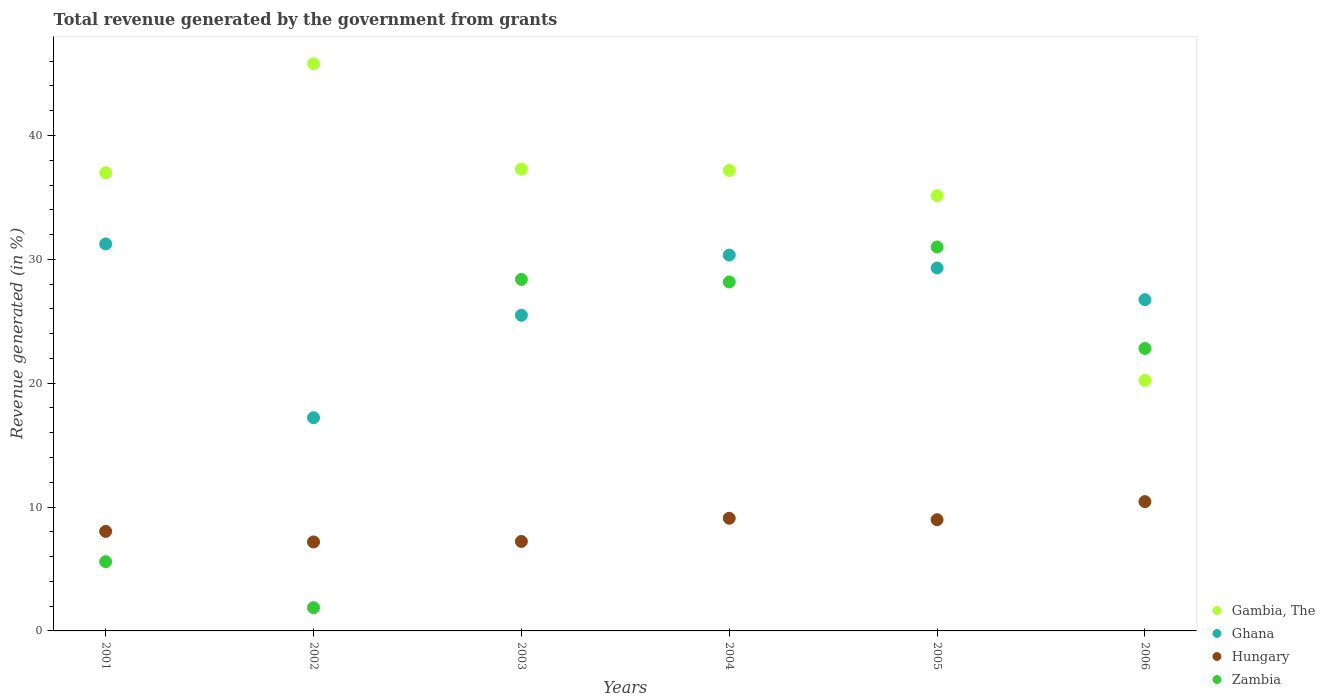How many different coloured dotlines are there?
Provide a succinct answer. 4. What is the total revenue generated in Gambia, The in 2005?
Provide a short and direct response. 35.15. Across all years, what is the maximum total revenue generated in Hungary?
Keep it short and to the point. 10.44. Across all years, what is the minimum total revenue generated in Ghana?
Provide a succinct answer. 17.21. What is the total total revenue generated in Gambia, The in the graph?
Offer a very short reply. 212.63. What is the difference between the total revenue generated in Zambia in 2003 and that in 2005?
Your answer should be compact. -2.62. What is the difference between the total revenue generated in Gambia, The in 2002 and the total revenue generated in Ghana in 2003?
Your answer should be compact. 20.31. What is the average total revenue generated in Zambia per year?
Your answer should be very brief. 19.64. In the year 2001, what is the difference between the total revenue generated in Ghana and total revenue generated in Zambia?
Ensure brevity in your answer.  25.66. In how many years, is the total revenue generated in Ghana greater than 16 %?
Provide a short and direct response. 6. What is the ratio of the total revenue generated in Zambia in 2003 to that in 2004?
Provide a succinct answer. 1.01. Is the total revenue generated in Zambia in 2003 less than that in 2006?
Offer a very short reply. No. What is the difference between the highest and the second highest total revenue generated in Gambia, The?
Keep it short and to the point. 8.51. What is the difference between the highest and the lowest total revenue generated in Zambia?
Keep it short and to the point. 29.12. Is the sum of the total revenue generated in Ghana in 2002 and 2006 greater than the maximum total revenue generated in Hungary across all years?
Offer a very short reply. Yes. Does the total revenue generated in Hungary monotonically increase over the years?
Make the answer very short. No. Is the total revenue generated in Zambia strictly less than the total revenue generated in Ghana over the years?
Make the answer very short. No. How many dotlines are there?
Your answer should be very brief. 4. How many years are there in the graph?
Keep it short and to the point. 6. Are the values on the major ticks of Y-axis written in scientific E-notation?
Your response must be concise. No. Where does the legend appear in the graph?
Your answer should be very brief. Bottom right. How many legend labels are there?
Offer a very short reply. 4. What is the title of the graph?
Provide a short and direct response. Total revenue generated by the government from grants. Does "Madagascar" appear as one of the legend labels in the graph?
Provide a short and direct response. No. What is the label or title of the X-axis?
Offer a terse response. Years. What is the label or title of the Y-axis?
Offer a very short reply. Revenue generated (in %). What is the Revenue generated (in %) in Gambia, The in 2001?
Ensure brevity in your answer.  36.99. What is the Revenue generated (in %) of Ghana in 2001?
Ensure brevity in your answer.  31.25. What is the Revenue generated (in %) of Hungary in 2001?
Provide a short and direct response. 8.04. What is the Revenue generated (in %) of Zambia in 2001?
Your answer should be very brief. 5.59. What is the Revenue generated (in %) of Gambia, The in 2002?
Keep it short and to the point. 45.79. What is the Revenue generated (in %) of Ghana in 2002?
Make the answer very short. 17.21. What is the Revenue generated (in %) of Hungary in 2002?
Keep it short and to the point. 7.18. What is the Revenue generated (in %) of Zambia in 2002?
Your response must be concise. 1.88. What is the Revenue generated (in %) in Gambia, The in 2003?
Make the answer very short. 37.29. What is the Revenue generated (in %) in Ghana in 2003?
Your answer should be compact. 25.49. What is the Revenue generated (in %) of Hungary in 2003?
Ensure brevity in your answer.  7.22. What is the Revenue generated (in %) of Zambia in 2003?
Your response must be concise. 28.38. What is the Revenue generated (in %) in Gambia, The in 2004?
Offer a terse response. 37.18. What is the Revenue generated (in %) in Ghana in 2004?
Your answer should be compact. 30.35. What is the Revenue generated (in %) in Hungary in 2004?
Make the answer very short. 9.1. What is the Revenue generated (in %) of Zambia in 2004?
Ensure brevity in your answer.  28.18. What is the Revenue generated (in %) of Gambia, The in 2005?
Offer a terse response. 35.15. What is the Revenue generated (in %) in Ghana in 2005?
Make the answer very short. 29.3. What is the Revenue generated (in %) of Hungary in 2005?
Provide a succinct answer. 8.98. What is the Revenue generated (in %) in Zambia in 2005?
Provide a succinct answer. 31. What is the Revenue generated (in %) in Gambia, The in 2006?
Offer a very short reply. 20.23. What is the Revenue generated (in %) of Ghana in 2006?
Your response must be concise. 26.75. What is the Revenue generated (in %) in Hungary in 2006?
Provide a succinct answer. 10.44. What is the Revenue generated (in %) in Zambia in 2006?
Provide a short and direct response. 22.81. Across all years, what is the maximum Revenue generated (in %) of Gambia, The?
Your answer should be compact. 45.79. Across all years, what is the maximum Revenue generated (in %) of Ghana?
Your answer should be compact. 31.25. Across all years, what is the maximum Revenue generated (in %) in Hungary?
Ensure brevity in your answer.  10.44. Across all years, what is the maximum Revenue generated (in %) of Zambia?
Provide a short and direct response. 31. Across all years, what is the minimum Revenue generated (in %) of Gambia, The?
Offer a very short reply. 20.23. Across all years, what is the minimum Revenue generated (in %) of Ghana?
Provide a succinct answer. 17.21. Across all years, what is the minimum Revenue generated (in %) in Hungary?
Ensure brevity in your answer.  7.18. Across all years, what is the minimum Revenue generated (in %) in Zambia?
Give a very brief answer. 1.88. What is the total Revenue generated (in %) of Gambia, The in the graph?
Give a very brief answer. 212.63. What is the total Revenue generated (in %) of Ghana in the graph?
Provide a short and direct response. 160.34. What is the total Revenue generated (in %) of Hungary in the graph?
Keep it short and to the point. 50.96. What is the total Revenue generated (in %) in Zambia in the graph?
Provide a short and direct response. 117.83. What is the difference between the Revenue generated (in %) of Gambia, The in 2001 and that in 2002?
Your response must be concise. -8.8. What is the difference between the Revenue generated (in %) of Ghana in 2001 and that in 2002?
Ensure brevity in your answer.  14.04. What is the difference between the Revenue generated (in %) in Hungary in 2001 and that in 2002?
Provide a succinct answer. 0.85. What is the difference between the Revenue generated (in %) of Zambia in 2001 and that in 2002?
Your answer should be compact. 3.71. What is the difference between the Revenue generated (in %) in Gambia, The in 2001 and that in 2003?
Provide a short and direct response. -0.3. What is the difference between the Revenue generated (in %) in Ghana in 2001 and that in 2003?
Your response must be concise. 5.76. What is the difference between the Revenue generated (in %) of Hungary in 2001 and that in 2003?
Keep it short and to the point. 0.81. What is the difference between the Revenue generated (in %) of Zambia in 2001 and that in 2003?
Ensure brevity in your answer.  -22.79. What is the difference between the Revenue generated (in %) in Gambia, The in 2001 and that in 2004?
Offer a terse response. -0.19. What is the difference between the Revenue generated (in %) in Ghana in 2001 and that in 2004?
Offer a terse response. 0.9. What is the difference between the Revenue generated (in %) in Hungary in 2001 and that in 2004?
Offer a terse response. -1.06. What is the difference between the Revenue generated (in %) in Zambia in 2001 and that in 2004?
Your response must be concise. -22.59. What is the difference between the Revenue generated (in %) of Gambia, The in 2001 and that in 2005?
Your response must be concise. 1.84. What is the difference between the Revenue generated (in %) in Ghana in 2001 and that in 2005?
Ensure brevity in your answer.  1.94. What is the difference between the Revenue generated (in %) in Hungary in 2001 and that in 2005?
Provide a short and direct response. -0.94. What is the difference between the Revenue generated (in %) of Zambia in 2001 and that in 2005?
Give a very brief answer. -25.41. What is the difference between the Revenue generated (in %) in Gambia, The in 2001 and that in 2006?
Your answer should be compact. 16.76. What is the difference between the Revenue generated (in %) in Ghana in 2001 and that in 2006?
Offer a terse response. 4.5. What is the difference between the Revenue generated (in %) of Hungary in 2001 and that in 2006?
Provide a short and direct response. -2.4. What is the difference between the Revenue generated (in %) of Zambia in 2001 and that in 2006?
Ensure brevity in your answer.  -17.22. What is the difference between the Revenue generated (in %) of Gambia, The in 2002 and that in 2003?
Your response must be concise. 8.51. What is the difference between the Revenue generated (in %) of Ghana in 2002 and that in 2003?
Your answer should be very brief. -8.27. What is the difference between the Revenue generated (in %) of Hungary in 2002 and that in 2003?
Offer a very short reply. -0.04. What is the difference between the Revenue generated (in %) in Zambia in 2002 and that in 2003?
Offer a very short reply. -26.51. What is the difference between the Revenue generated (in %) of Gambia, The in 2002 and that in 2004?
Keep it short and to the point. 8.61. What is the difference between the Revenue generated (in %) in Ghana in 2002 and that in 2004?
Your response must be concise. -13.14. What is the difference between the Revenue generated (in %) in Hungary in 2002 and that in 2004?
Provide a succinct answer. -1.91. What is the difference between the Revenue generated (in %) of Zambia in 2002 and that in 2004?
Keep it short and to the point. -26.3. What is the difference between the Revenue generated (in %) in Gambia, The in 2002 and that in 2005?
Ensure brevity in your answer.  10.65. What is the difference between the Revenue generated (in %) of Ghana in 2002 and that in 2005?
Ensure brevity in your answer.  -12.09. What is the difference between the Revenue generated (in %) in Hungary in 2002 and that in 2005?
Give a very brief answer. -1.79. What is the difference between the Revenue generated (in %) of Zambia in 2002 and that in 2005?
Ensure brevity in your answer.  -29.12. What is the difference between the Revenue generated (in %) of Gambia, The in 2002 and that in 2006?
Your answer should be very brief. 25.56. What is the difference between the Revenue generated (in %) of Ghana in 2002 and that in 2006?
Make the answer very short. -9.54. What is the difference between the Revenue generated (in %) of Hungary in 2002 and that in 2006?
Make the answer very short. -3.26. What is the difference between the Revenue generated (in %) in Zambia in 2002 and that in 2006?
Your answer should be very brief. -20.93. What is the difference between the Revenue generated (in %) of Gambia, The in 2003 and that in 2004?
Provide a succinct answer. 0.11. What is the difference between the Revenue generated (in %) in Ghana in 2003 and that in 2004?
Give a very brief answer. -4.86. What is the difference between the Revenue generated (in %) in Hungary in 2003 and that in 2004?
Your answer should be very brief. -1.87. What is the difference between the Revenue generated (in %) of Zambia in 2003 and that in 2004?
Provide a short and direct response. 0.2. What is the difference between the Revenue generated (in %) of Gambia, The in 2003 and that in 2005?
Offer a terse response. 2.14. What is the difference between the Revenue generated (in %) in Ghana in 2003 and that in 2005?
Keep it short and to the point. -3.82. What is the difference between the Revenue generated (in %) in Hungary in 2003 and that in 2005?
Your response must be concise. -1.76. What is the difference between the Revenue generated (in %) in Zambia in 2003 and that in 2005?
Keep it short and to the point. -2.62. What is the difference between the Revenue generated (in %) in Gambia, The in 2003 and that in 2006?
Your answer should be compact. 17.06. What is the difference between the Revenue generated (in %) in Ghana in 2003 and that in 2006?
Keep it short and to the point. -1.26. What is the difference between the Revenue generated (in %) of Hungary in 2003 and that in 2006?
Your response must be concise. -3.22. What is the difference between the Revenue generated (in %) in Zambia in 2003 and that in 2006?
Your answer should be compact. 5.58. What is the difference between the Revenue generated (in %) in Gambia, The in 2004 and that in 2005?
Provide a succinct answer. 2.04. What is the difference between the Revenue generated (in %) of Ghana in 2004 and that in 2005?
Make the answer very short. 1.04. What is the difference between the Revenue generated (in %) in Hungary in 2004 and that in 2005?
Make the answer very short. 0.12. What is the difference between the Revenue generated (in %) of Zambia in 2004 and that in 2005?
Offer a very short reply. -2.82. What is the difference between the Revenue generated (in %) of Gambia, The in 2004 and that in 2006?
Ensure brevity in your answer.  16.95. What is the difference between the Revenue generated (in %) of Ghana in 2004 and that in 2006?
Give a very brief answer. 3.6. What is the difference between the Revenue generated (in %) of Hungary in 2004 and that in 2006?
Keep it short and to the point. -1.35. What is the difference between the Revenue generated (in %) of Zambia in 2004 and that in 2006?
Offer a terse response. 5.37. What is the difference between the Revenue generated (in %) in Gambia, The in 2005 and that in 2006?
Provide a short and direct response. 14.92. What is the difference between the Revenue generated (in %) of Ghana in 2005 and that in 2006?
Ensure brevity in your answer.  2.56. What is the difference between the Revenue generated (in %) in Hungary in 2005 and that in 2006?
Provide a succinct answer. -1.46. What is the difference between the Revenue generated (in %) in Zambia in 2005 and that in 2006?
Give a very brief answer. 8.19. What is the difference between the Revenue generated (in %) of Gambia, The in 2001 and the Revenue generated (in %) of Ghana in 2002?
Your response must be concise. 19.78. What is the difference between the Revenue generated (in %) in Gambia, The in 2001 and the Revenue generated (in %) in Hungary in 2002?
Give a very brief answer. 29.81. What is the difference between the Revenue generated (in %) in Gambia, The in 2001 and the Revenue generated (in %) in Zambia in 2002?
Provide a succinct answer. 35.12. What is the difference between the Revenue generated (in %) of Ghana in 2001 and the Revenue generated (in %) of Hungary in 2002?
Make the answer very short. 24.06. What is the difference between the Revenue generated (in %) in Ghana in 2001 and the Revenue generated (in %) in Zambia in 2002?
Make the answer very short. 29.37. What is the difference between the Revenue generated (in %) of Hungary in 2001 and the Revenue generated (in %) of Zambia in 2002?
Keep it short and to the point. 6.16. What is the difference between the Revenue generated (in %) of Gambia, The in 2001 and the Revenue generated (in %) of Ghana in 2003?
Give a very brief answer. 11.51. What is the difference between the Revenue generated (in %) in Gambia, The in 2001 and the Revenue generated (in %) in Hungary in 2003?
Provide a short and direct response. 29.77. What is the difference between the Revenue generated (in %) in Gambia, The in 2001 and the Revenue generated (in %) in Zambia in 2003?
Provide a short and direct response. 8.61. What is the difference between the Revenue generated (in %) in Ghana in 2001 and the Revenue generated (in %) in Hungary in 2003?
Offer a terse response. 24.02. What is the difference between the Revenue generated (in %) of Ghana in 2001 and the Revenue generated (in %) of Zambia in 2003?
Make the answer very short. 2.87. What is the difference between the Revenue generated (in %) in Hungary in 2001 and the Revenue generated (in %) in Zambia in 2003?
Offer a very short reply. -20.35. What is the difference between the Revenue generated (in %) of Gambia, The in 2001 and the Revenue generated (in %) of Ghana in 2004?
Offer a terse response. 6.65. What is the difference between the Revenue generated (in %) of Gambia, The in 2001 and the Revenue generated (in %) of Hungary in 2004?
Ensure brevity in your answer.  27.9. What is the difference between the Revenue generated (in %) in Gambia, The in 2001 and the Revenue generated (in %) in Zambia in 2004?
Offer a very short reply. 8.81. What is the difference between the Revenue generated (in %) in Ghana in 2001 and the Revenue generated (in %) in Hungary in 2004?
Make the answer very short. 22.15. What is the difference between the Revenue generated (in %) of Ghana in 2001 and the Revenue generated (in %) of Zambia in 2004?
Your response must be concise. 3.07. What is the difference between the Revenue generated (in %) of Hungary in 2001 and the Revenue generated (in %) of Zambia in 2004?
Offer a terse response. -20.14. What is the difference between the Revenue generated (in %) in Gambia, The in 2001 and the Revenue generated (in %) in Ghana in 2005?
Provide a short and direct response. 7.69. What is the difference between the Revenue generated (in %) in Gambia, The in 2001 and the Revenue generated (in %) in Hungary in 2005?
Provide a short and direct response. 28.01. What is the difference between the Revenue generated (in %) in Gambia, The in 2001 and the Revenue generated (in %) in Zambia in 2005?
Your answer should be very brief. 5.99. What is the difference between the Revenue generated (in %) in Ghana in 2001 and the Revenue generated (in %) in Hungary in 2005?
Keep it short and to the point. 22.27. What is the difference between the Revenue generated (in %) in Ghana in 2001 and the Revenue generated (in %) in Zambia in 2005?
Your answer should be compact. 0.25. What is the difference between the Revenue generated (in %) of Hungary in 2001 and the Revenue generated (in %) of Zambia in 2005?
Keep it short and to the point. -22.96. What is the difference between the Revenue generated (in %) in Gambia, The in 2001 and the Revenue generated (in %) in Ghana in 2006?
Keep it short and to the point. 10.24. What is the difference between the Revenue generated (in %) in Gambia, The in 2001 and the Revenue generated (in %) in Hungary in 2006?
Make the answer very short. 26.55. What is the difference between the Revenue generated (in %) of Gambia, The in 2001 and the Revenue generated (in %) of Zambia in 2006?
Offer a very short reply. 14.19. What is the difference between the Revenue generated (in %) in Ghana in 2001 and the Revenue generated (in %) in Hungary in 2006?
Your answer should be very brief. 20.81. What is the difference between the Revenue generated (in %) in Ghana in 2001 and the Revenue generated (in %) in Zambia in 2006?
Your answer should be very brief. 8.44. What is the difference between the Revenue generated (in %) of Hungary in 2001 and the Revenue generated (in %) of Zambia in 2006?
Your answer should be compact. -14.77. What is the difference between the Revenue generated (in %) of Gambia, The in 2002 and the Revenue generated (in %) of Ghana in 2003?
Keep it short and to the point. 20.31. What is the difference between the Revenue generated (in %) of Gambia, The in 2002 and the Revenue generated (in %) of Hungary in 2003?
Make the answer very short. 38.57. What is the difference between the Revenue generated (in %) in Gambia, The in 2002 and the Revenue generated (in %) in Zambia in 2003?
Give a very brief answer. 17.41. What is the difference between the Revenue generated (in %) in Ghana in 2002 and the Revenue generated (in %) in Hungary in 2003?
Your answer should be very brief. 9.99. What is the difference between the Revenue generated (in %) of Ghana in 2002 and the Revenue generated (in %) of Zambia in 2003?
Provide a succinct answer. -11.17. What is the difference between the Revenue generated (in %) in Hungary in 2002 and the Revenue generated (in %) in Zambia in 2003?
Provide a short and direct response. -21.2. What is the difference between the Revenue generated (in %) of Gambia, The in 2002 and the Revenue generated (in %) of Ghana in 2004?
Provide a succinct answer. 15.45. What is the difference between the Revenue generated (in %) of Gambia, The in 2002 and the Revenue generated (in %) of Hungary in 2004?
Give a very brief answer. 36.7. What is the difference between the Revenue generated (in %) of Gambia, The in 2002 and the Revenue generated (in %) of Zambia in 2004?
Offer a very short reply. 17.61. What is the difference between the Revenue generated (in %) in Ghana in 2002 and the Revenue generated (in %) in Hungary in 2004?
Your response must be concise. 8.12. What is the difference between the Revenue generated (in %) in Ghana in 2002 and the Revenue generated (in %) in Zambia in 2004?
Your answer should be very brief. -10.97. What is the difference between the Revenue generated (in %) of Hungary in 2002 and the Revenue generated (in %) of Zambia in 2004?
Give a very brief answer. -20.99. What is the difference between the Revenue generated (in %) in Gambia, The in 2002 and the Revenue generated (in %) in Ghana in 2005?
Give a very brief answer. 16.49. What is the difference between the Revenue generated (in %) in Gambia, The in 2002 and the Revenue generated (in %) in Hungary in 2005?
Your response must be concise. 36.81. What is the difference between the Revenue generated (in %) in Gambia, The in 2002 and the Revenue generated (in %) in Zambia in 2005?
Your response must be concise. 14.8. What is the difference between the Revenue generated (in %) in Ghana in 2002 and the Revenue generated (in %) in Hungary in 2005?
Keep it short and to the point. 8.23. What is the difference between the Revenue generated (in %) of Ghana in 2002 and the Revenue generated (in %) of Zambia in 2005?
Your answer should be very brief. -13.79. What is the difference between the Revenue generated (in %) of Hungary in 2002 and the Revenue generated (in %) of Zambia in 2005?
Give a very brief answer. -23.81. What is the difference between the Revenue generated (in %) in Gambia, The in 2002 and the Revenue generated (in %) in Ghana in 2006?
Give a very brief answer. 19.05. What is the difference between the Revenue generated (in %) in Gambia, The in 2002 and the Revenue generated (in %) in Hungary in 2006?
Give a very brief answer. 35.35. What is the difference between the Revenue generated (in %) of Gambia, The in 2002 and the Revenue generated (in %) of Zambia in 2006?
Ensure brevity in your answer.  22.99. What is the difference between the Revenue generated (in %) of Ghana in 2002 and the Revenue generated (in %) of Hungary in 2006?
Make the answer very short. 6.77. What is the difference between the Revenue generated (in %) of Ghana in 2002 and the Revenue generated (in %) of Zambia in 2006?
Provide a short and direct response. -5.6. What is the difference between the Revenue generated (in %) in Hungary in 2002 and the Revenue generated (in %) in Zambia in 2006?
Provide a succinct answer. -15.62. What is the difference between the Revenue generated (in %) in Gambia, The in 2003 and the Revenue generated (in %) in Ghana in 2004?
Provide a short and direct response. 6.94. What is the difference between the Revenue generated (in %) in Gambia, The in 2003 and the Revenue generated (in %) in Hungary in 2004?
Your response must be concise. 28.19. What is the difference between the Revenue generated (in %) of Gambia, The in 2003 and the Revenue generated (in %) of Zambia in 2004?
Make the answer very short. 9.11. What is the difference between the Revenue generated (in %) of Ghana in 2003 and the Revenue generated (in %) of Hungary in 2004?
Offer a terse response. 16.39. What is the difference between the Revenue generated (in %) in Ghana in 2003 and the Revenue generated (in %) in Zambia in 2004?
Your answer should be very brief. -2.69. What is the difference between the Revenue generated (in %) of Hungary in 2003 and the Revenue generated (in %) of Zambia in 2004?
Make the answer very short. -20.95. What is the difference between the Revenue generated (in %) in Gambia, The in 2003 and the Revenue generated (in %) in Ghana in 2005?
Provide a short and direct response. 7.98. What is the difference between the Revenue generated (in %) of Gambia, The in 2003 and the Revenue generated (in %) of Hungary in 2005?
Make the answer very short. 28.31. What is the difference between the Revenue generated (in %) of Gambia, The in 2003 and the Revenue generated (in %) of Zambia in 2005?
Your response must be concise. 6.29. What is the difference between the Revenue generated (in %) of Ghana in 2003 and the Revenue generated (in %) of Hungary in 2005?
Your answer should be very brief. 16.51. What is the difference between the Revenue generated (in %) in Ghana in 2003 and the Revenue generated (in %) in Zambia in 2005?
Your answer should be very brief. -5.51. What is the difference between the Revenue generated (in %) in Hungary in 2003 and the Revenue generated (in %) in Zambia in 2005?
Your answer should be very brief. -23.77. What is the difference between the Revenue generated (in %) of Gambia, The in 2003 and the Revenue generated (in %) of Ghana in 2006?
Offer a terse response. 10.54. What is the difference between the Revenue generated (in %) of Gambia, The in 2003 and the Revenue generated (in %) of Hungary in 2006?
Keep it short and to the point. 26.85. What is the difference between the Revenue generated (in %) in Gambia, The in 2003 and the Revenue generated (in %) in Zambia in 2006?
Your response must be concise. 14.48. What is the difference between the Revenue generated (in %) in Ghana in 2003 and the Revenue generated (in %) in Hungary in 2006?
Ensure brevity in your answer.  15.04. What is the difference between the Revenue generated (in %) in Ghana in 2003 and the Revenue generated (in %) in Zambia in 2006?
Keep it short and to the point. 2.68. What is the difference between the Revenue generated (in %) in Hungary in 2003 and the Revenue generated (in %) in Zambia in 2006?
Make the answer very short. -15.58. What is the difference between the Revenue generated (in %) in Gambia, The in 2004 and the Revenue generated (in %) in Ghana in 2005?
Provide a succinct answer. 7.88. What is the difference between the Revenue generated (in %) of Gambia, The in 2004 and the Revenue generated (in %) of Hungary in 2005?
Offer a very short reply. 28.2. What is the difference between the Revenue generated (in %) of Gambia, The in 2004 and the Revenue generated (in %) of Zambia in 2005?
Give a very brief answer. 6.18. What is the difference between the Revenue generated (in %) of Ghana in 2004 and the Revenue generated (in %) of Hungary in 2005?
Offer a terse response. 21.37. What is the difference between the Revenue generated (in %) in Ghana in 2004 and the Revenue generated (in %) in Zambia in 2005?
Give a very brief answer. -0.65. What is the difference between the Revenue generated (in %) in Hungary in 2004 and the Revenue generated (in %) in Zambia in 2005?
Give a very brief answer. -21.9. What is the difference between the Revenue generated (in %) of Gambia, The in 2004 and the Revenue generated (in %) of Ghana in 2006?
Keep it short and to the point. 10.44. What is the difference between the Revenue generated (in %) of Gambia, The in 2004 and the Revenue generated (in %) of Hungary in 2006?
Keep it short and to the point. 26.74. What is the difference between the Revenue generated (in %) in Gambia, The in 2004 and the Revenue generated (in %) in Zambia in 2006?
Make the answer very short. 14.38. What is the difference between the Revenue generated (in %) of Ghana in 2004 and the Revenue generated (in %) of Hungary in 2006?
Ensure brevity in your answer.  19.91. What is the difference between the Revenue generated (in %) of Ghana in 2004 and the Revenue generated (in %) of Zambia in 2006?
Provide a succinct answer. 7.54. What is the difference between the Revenue generated (in %) in Hungary in 2004 and the Revenue generated (in %) in Zambia in 2006?
Make the answer very short. -13.71. What is the difference between the Revenue generated (in %) in Gambia, The in 2005 and the Revenue generated (in %) in Ghana in 2006?
Your answer should be very brief. 8.4. What is the difference between the Revenue generated (in %) in Gambia, The in 2005 and the Revenue generated (in %) in Hungary in 2006?
Your answer should be very brief. 24.71. What is the difference between the Revenue generated (in %) of Gambia, The in 2005 and the Revenue generated (in %) of Zambia in 2006?
Your answer should be very brief. 12.34. What is the difference between the Revenue generated (in %) of Ghana in 2005 and the Revenue generated (in %) of Hungary in 2006?
Keep it short and to the point. 18.86. What is the difference between the Revenue generated (in %) in Ghana in 2005 and the Revenue generated (in %) in Zambia in 2006?
Your response must be concise. 6.5. What is the difference between the Revenue generated (in %) of Hungary in 2005 and the Revenue generated (in %) of Zambia in 2006?
Your answer should be compact. -13.83. What is the average Revenue generated (in %) in Gambia, The per year?
Your answer should be compact. 35.44. What is the average Revenue generated (in %) in Ghana per year?
Your answer should be very brief. 26.72. What is the average Revenue generated (in %) in Hungary per year?
Give a very brief answer. 8.49. What is the average Revenue generated (in %) in Zambia per year?
Offer a very short reply. 19.64. In the year 2001, what is the difference between the Revenue generated (in %) of Gambia, The and Revenue generated (in %) of Ghana?
Ensure brevity in your answer.  5.74. In the year 2001, what is the difference between the Revenue generated (in %) of Gambia, The and Revenue generated (in %) of Hungary?
Offer a very short reply. 28.96. In the year 2001, what is the difference between the Revenue generated (in %) of Gambia, The and Revenue generated (in %) of Zambia?
Ensure brevity in your answer.  31.4. In the year 2001, what is the difference between the Revenue generated (in %) in Ghana and Revenue generated (in %) in Hungary?
Offer a very short reply. 23.21. In the year 2001, what is the difference between the Revenue generated (in %) of Ghana and Revenue generated (in %) of Zambia?
Provide a short and direct response. 25.66. In the year 2001, what is the difference between the Revenue generated (in %) in Hungary and Revenue generated (in %) in Zambia?
Provide a succinct answer. 2.45. In the year 2002, what is the difference between the Revenue generated (in %) in Gambia, The and Revenue generated (in %) in Ghana?
Give a very brief answer. 28.58. In the year 2002, what is the difference between the Revenue generated (in %) of Gambia, The and Revenue generated (in %) of Hungary?
Keep it short and to the point. 38.61. In the year 2002, what is the difference between the Revenue generated (in %) in Gambia, The and Revenue generated (in %) in Zambia?
Provide a succinct answer. 43.92. In the year 2002, what is the difference between the Revenue generated (in %) in Ghana and Revenue generated (in %) in Hungary?
Ensure brevity in your answer.  10.03. In the year 2002, what is the difference between the Revenue generated (in %) in Ghana and Revenue generated (in %) in Zambia?
Offer a very short reply. 15.34. In the year 2002, what is the difference between the Revenue generated (in %) of Hungary and Revenue generated (in %) of Zambia?
Provide a short and direct response. 5.31. In the year 2003, what is the difference between the Revenue generated (in %) in Gambia, The and Revenue generated (in %) in Ghana?
Your response must be concise. 11.8. In the year 2003, what is the difference between the Revenue generated (in %) in Gambia, The and Revenue generated (in %) in Hungary?
Your answer should be very brief. 30.06. In the year 2003, what is the difference between the Revenue generated (in %) of Gambia, The and Revenue generated (in %) of Zambia?
Keep it short and to the point. 8.9. In the year 2003, what is the difference between the Revenue generated (in %) in Ghana and Revenue generated (in %) in Hungary?
Ensure brevity in your answer.  18.26. In the year 2003, what is the difference between the Revenue generated (in %) of Ghana and Revenue generated (in %) of Zambia?
Offer a terse response. -2.9. In the year 2003, what is the difference between the Revenue generated (in %) of Hungary and Revenue generated (in %) of Zambia?
Offer a very short reply. -21.16. In the year 2004, what is the difference between the Revenue generated (in %) of Gambia, The and Revenue generated (in %) of Ghana?
Make the answer very short. 6.84. In the year 2004, what is the difference between the Revenue generated (in %) of Gambia, The and Revenue generated (in %) of Hungary?
Make the answer very short. 28.09. In the year 2004, what is the difference between the Revenue generated (in %) of Gambia, The and Revenue generated (in %) of Zambia?
Give a very brief answer. 9. In the year 2004, what is the difference between the Revenue generated (in %) of Ghana and Revenue generated (in %) of Hungary?
Your response must be concise. 21.25. In the year 2004, what is the difference between the Revenue generated (in %) of Ghana and Revenue generated (in %) of Zambia?
Your response must be concise. 2.17. In the year 2004, what is the difference between the Revenue generated (in %) in Hungary and Revenue generated (in %) in Zambia?
Your answer should be very brief. -19.08. In the year 2005, what is the difference between the Revenue generated (in %) in Gambia, The and Revenue generated (in %) in Ghana?
Ensure brevity in your answer.  5.84. In the year 2005, what is the difference between the Revenue generated (in %) of Gambia, The and Revenue generated (in %) of Hungary?
Provide a short and direct response. 26.17. In the year 2005, what is the difference between the Revenue generated (in %) in Gambia, The and Revenue generated (in %) in Zambia?
Your response must be concise. 4.15. In the year 2005, what is the difference between the Revenue generated (in %) in Ghana and Revenue generated (in %) in Hungary?
Keep it short and to the point. 20.32. In the year 2005, what is the difference between the Revenue generated (in %) in Ghana and Revenue generated (in %) in Zambia?
Make the answer very short. -1.7. In the year 2005, what is the difference between the Revenue generated (in %) of Hungary and Revenue generated (in %) of Zambia?
Your response must be concise. -22.02. In the year 2006, what is the difference between the Revenue generated (in %) in Gambia, The and Revenue generated (in %) in Ghana?
Give a very brief answer. -6.52. In the year 2006, what is the difference between the Revenue generated (in %) of Gambia, The and Revenue generated (in %) of Hungary?
Your answer should be compact. 9.79. In the year 2006, what is the difference between the Revenue generated (in %) of Gambia, The and Revenue generated (in %) of Zambia?
Provide a short and direct response. -2.58. In the year 2006, what is the difference between the Revenue generated (in %) in Ghana and Revenue generated (in %) in Hungary?
Ensure brevity in your answer.  16.31. In the year 2006, what is the difference between the Revenue generated (in %) in Ghana and Revenue generated (in %) in Zambia?
Give a very brief answer. 3.94. In the year 2006, what is the difference between the Revenue generated (in %) in Hungary and Revenue generated (in %) in Zambia?
Your answer should be compact. -12.37. What is the ratio of the Revenue generated (in %) of Gambia, The in 2001 to that in 2002?
Your answer should be compact. 0.81. What is the ratio of the Revenue generated (in %) in Ghana in 2001 to that in 2002?
Your answer should be compact. 1.82. What is the ratio of the Revenue generated (in %) in Hungary in 2001 to that in 2002?
Your answer should be compact. 1.12. What is the ratio of the Revenue generated (in %) of Zambia in 2001 to that in 2002?
Your answer should be compact. 2.98. What is the ratio of the Revenue generated (in %) of Gambia, The in 2001 to that in 2003?
Make the answer very short. 0.99. What is the ratio of the Revenue generated (in %) in Ghana in 2001 to that in 2003?
Offer a terse response. 1.23. What is the ratio of the Revenue generated (in %) in Hungary in 2001 to that in 2003?
Offer a very short reply. 1.11. What is the ratio of the Revenue generated (in %) of Zambia in 2001 to that in 2003?
Make the answer very short. 0.2. What is the ratio of the Revenue generated (in %) in Ghana in 2001 to that in 2004?
Provide a succinct answer. 1.03. What is the ratio of the Revenue generated (in %) in Hungary in 2001 to that in 2004?
Offer a very short reply. 0.88. What is the ratio of the Revenue generated (in %) of Zambia in 2001 to that in 2004?
Your response must be concise. 0.2. What is the ratio of the Revenue generated (in %) of Gambia, The in 2001 to that in 2005?
Keep it short and to the point. 1.05. What is the ratio of the Revenue generated (in %) in Ghana in 2001 to that in 2005?
Give a very brief answer. 1.07. What is the ratio of the Revenue generated (in %) of Hungary in 2001 to that in 2005?
Provide a short and direct response. 0.9. What is the ratio of the Revenue generated (in %) of Zambia in 2001 to that in 2005?
Provide a short and direct response. 0.18. What is the ratio of the Revenue generated (in %) of Gambia, The in 2001 to that in 2006?
Ensure brevity in your answer.  1.83. What is the ratio of the Revenue generated (in %) of Ghana in 2001 to that in 2006?
Make the answer very short. 1.17. What is the ratio of the Revenue generated (in %) of Hungary in 2001 to that in 2006?
Offer a very short reply. 0.77. What is the ratio of the Revenue generated (in %) of Zambia in 2001 to that in 2006?
Ensure brevity in your answer.  0.25. What is the ratio of the Revenue generated (in %) in Gambia, The in 2002 to that in 2003?
Your answer should be compact. 1.23. What is the ratio of the Revenue generated (in %) in Ghana in 2002 to that in 2003?
Give a very brief answer. 0.68. What is the ratio of the Revenue generated (in %) of Zambia in 2002 to that in 2003?
Your answer should be compact. 0.07. What is the ratio of the Revenue generated (in %) in Gambia, The in 2002 to that in 2004?
Your answer should be very brief. 1.23. What is the ratio of the Revenue generated (in %) of Ghana in 2002 to that in 2004?
Provide a short and direct response. 0.57. What is the ratio of the Revenue generated (in %) of Hungary in 2002 to that in 2004?
Keep it short and to the point. 0.79. What is the ratio of the Revenue generated (in %) in Zambia in 2002 to that in 2004?
Give a very brief answer. 0.07. What is the ratio of the Revenue generated (in %) of Gambia, The in 2002 to that in 2005?
Your response must be concise. 1.3. What is the ratio of the Revenue generated (in %) in Ghana in 2002 to that in 2005?
Provide a short and direct response. 0.59. What is the ratio of the Revenue generated (in %) in Hungary in 2002 to that in 2005?
Make the answer very short. 0.8. What is the ratio of the Revenue generated (in %) in Zambia in 2002 to that in 2005?
Offer a terse response. 0.06. What is the ratio of the Revenue generated (in %) in Gambia, The in 2002 to that in 2006?
Offer a very short reply. 2.26. What is the ratio of the Revenue generated (in %) in Ghana in 2002 to that in 2006?
Provide a short and direct response. 0.64. What is the ratio of the Revenue generated (in %) in Hungary in 2002 to that in 2006?
Provide a short and direct response. 0.69. What is the ratio of the Revenue generated (in %) in Zambia in 2002 to that in 2006?
Ensure brevity in your answer.  0.08. What is the ratio of the Revenue generated (in %) of Ghana in 2003 to that in 2004?
Provide a short and direct response. 0.84. What is the ratio of the Revenue generated (in %) of Hungary in 2003 to that in 2004?
Provide a short and direct response. 0.79. What is the ratio of the Revenue generated (in %) in Gambia, The in 2003 to that in 2005?
Provide a succinct answer. 1.06. What is the ratio of the Revenue generated (in %) of Ghana in 2003 to that in 2005?
Offer a very short reply. 0.87. What is the ratio of the Revenue generated (in %) of Hungary in 2003 to that in 2005?
Offer a very short reply. 0.8. What is the ratio of the Revenue generated (in %) of Zambia in 2003 to that in 2005?
Provide a short and direct response. 0.92. What is the ratio of the Revenue generated (in %) of Gambia, The in 2003 to that in 2006?
Make the answer very short. 1.84. What is the ratio of the Revenue generated (in %) of Ghana in 2003 to that in 2006?
Your answer should be compact. 0.95. What is the ratio of the Revenue generated (in %) of Hungary in 2003 to that in 2006?
Offer a terse response. 0.69. What is the ratio of the Revenue generated (in %) in Zambia in 2003 to that in 2006?
Your answer should be compact. 1.24. What is the ratio of the Revenue generated (in %) in Gambia, The in 2004 to that in 2005?
Give a very brief answer. 1.06. What is the ratio of the Revenue generated (in %) in Ghana in 2004 to that in 2005?
Keep it short and to the point. 1.04. What is the ratio of the Revenue generated (in %) in Hungary in 2004 to that in 2005?
Your answer should be very brief. 1.01. What is the ratio of the Revenue generated (in %) of Zambia in 2004 to that in 2005?
Your response must be concise. 0.91. What is the ratio of the Revenue generated (in %) of Gambia, The in 2004 to that in 2006?
Offer a terse response. 1.84. What is the ratio of the Revenue generated (in %) of Ghana in 2004 to that in 2006?
Make the answer very short. 1.13. What is the ratio of the Revenue generated (in %) in Hungary in 2004 to that in 2006?
Your answer should be very brief. 0.87. What is the ratio of the Revenue generated (in %) in Zambia in 2004 to that in 2006?
Offer a terse response. 1.24. What is the ratio of the Revenue generated (in %) of Gambia, The in 2005 to that in 2006?
Your answer should be compact. 1.74. What is the ratio of the Revenue generated (in %) of Ghana in 2005 to that in 2006?
Keep it short and to the point. 1.1. What is the ratio of the Revenue generated (in %) in Hungary in 2005 to that in 2006?
Keep it short and to the point. 0.86. What is the ratio of the Revenue generated (in %) in Zambia in 2005 to that in 2006?
Offer a very short reply. 1.36. What is the difference between the highest and the second highest Revenue generated (in %) of Gambia, The?
Provide a succinct answer. 8.51. What is the difference between the highest and the second highest Revenue generated (in %) of Ghana?
Keep it short and to the point. 0.9. What is the difference between the highest and the second highest Revenue generated (in %) of Hungary?
Provide a succinct answer. 1.35. What is the difference between the highest and the second highest Revenue generated (in %) in Zambia?
Make the answer very short. 2.62. What is the difference between the highest and the lowest Revenue generated (in %) of Gambia, The?
Your response must be concise. 25.56. What is the difference between the highest and the lowest Revenue generated (in %) of Ghana?
Give a very brief answer. 14.04. What is the difference between the highest and the lowest Revenue generated (in %) of Hungary?
Offer a very short reply. 3.26. What is the difference between the highest and the lowest Revenue generated (in %) in Zambia?
Your answer should be very brief. 29.12. 